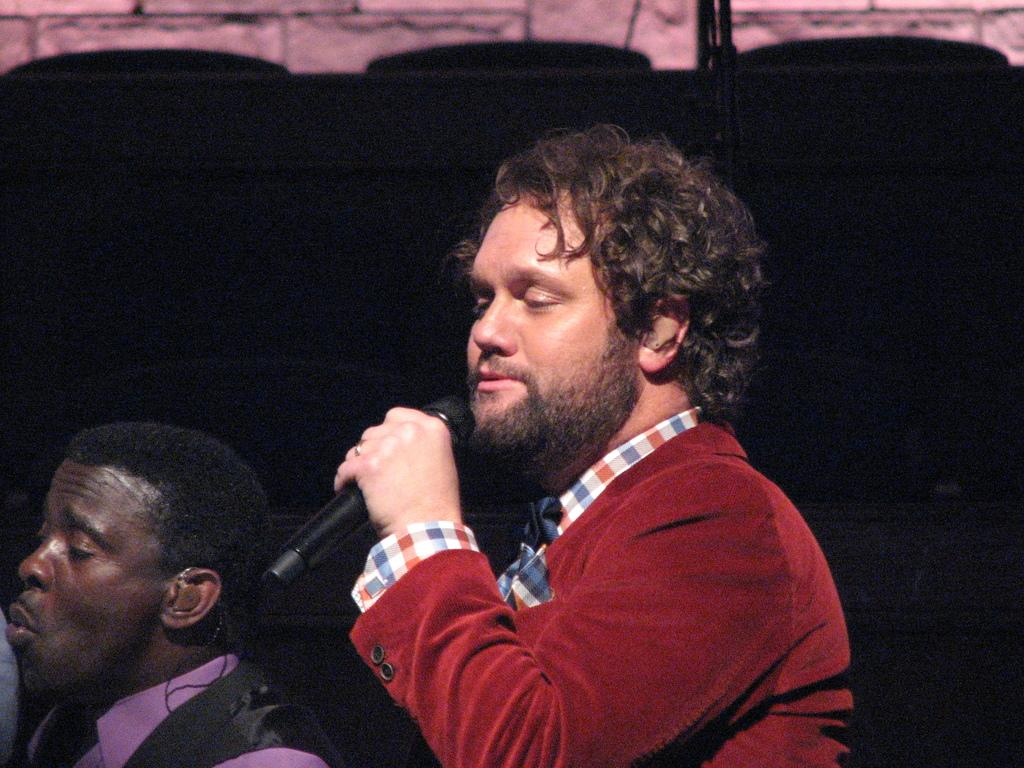How many people are in the image? There are two men in the image. What are the men doing in the image? The men are singing in the image. Can you describe the man holding an object in the image? One of the men is holding a microphone in the image. What is the color of the background in the image? The background of the image is dark. Can you tell me how many guns are visible in the image? There are no guns present in the image. What type of holiday is being celebrated in the image? There is no indication of a holiday being celebrated in the image. 